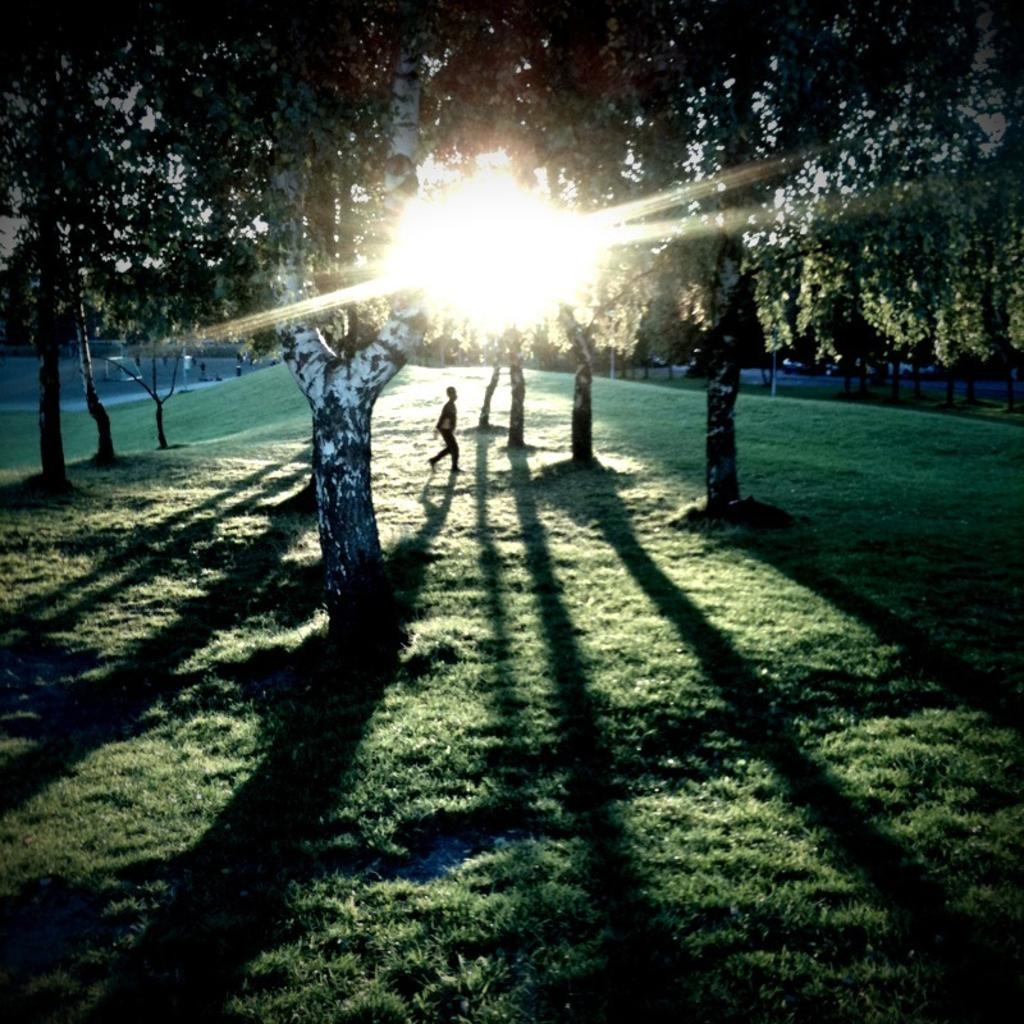What type of vegetation can be seen in the image? There are trees in the image. What is the boy doing in the image? The boy is walking at the center of the image. What is the source of light in the image? The sun is visible in the image. What type of ground surface is present at the bottom of the image? There is grass at the bottom of the image. What type of whip can be seen in the boy's hand in the image? There is no whip present in the image; the boy is simply walking. What language is the boy speaking in the image? There is no indication of the language being spoken in the image, as it does not include any audio or text. 